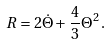Convert formula to latex. <formula><loc_0><loc_0><loc_500><loc_500>R = 2 \dot { \Theta } + \frac { 4 } { 3 } \Theta ^ { 2 } \, .</formula> 